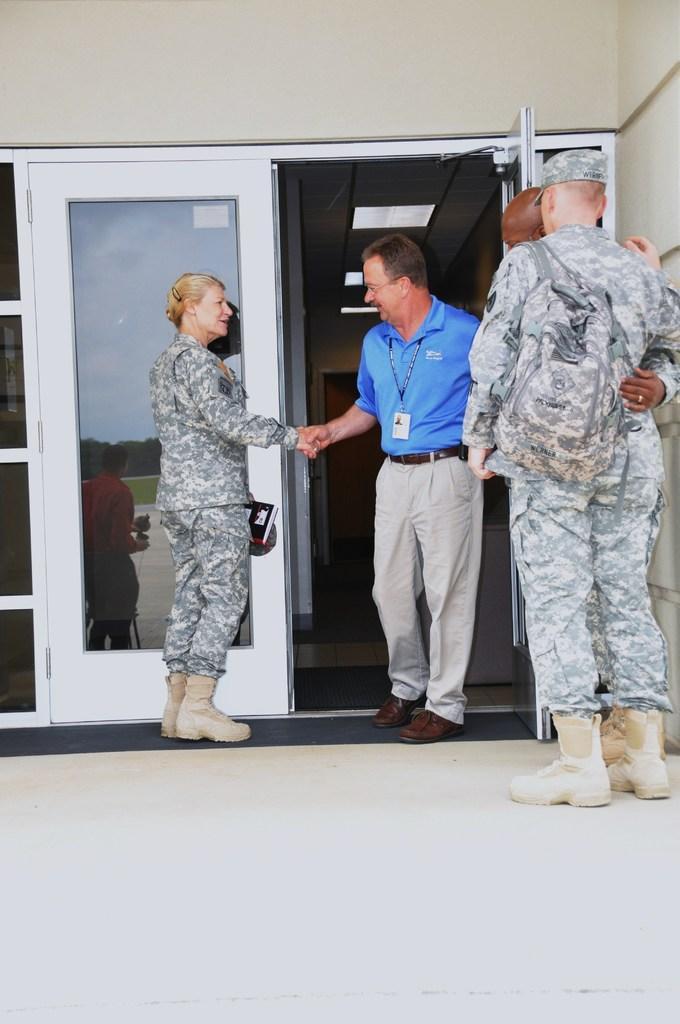Describe this image in one or two sentences. In this image we can see three men and one woman. Two men and one woman is wearing army uniform and one more man is wearing blue color t-shirt and pant. Behind white color door is there. 